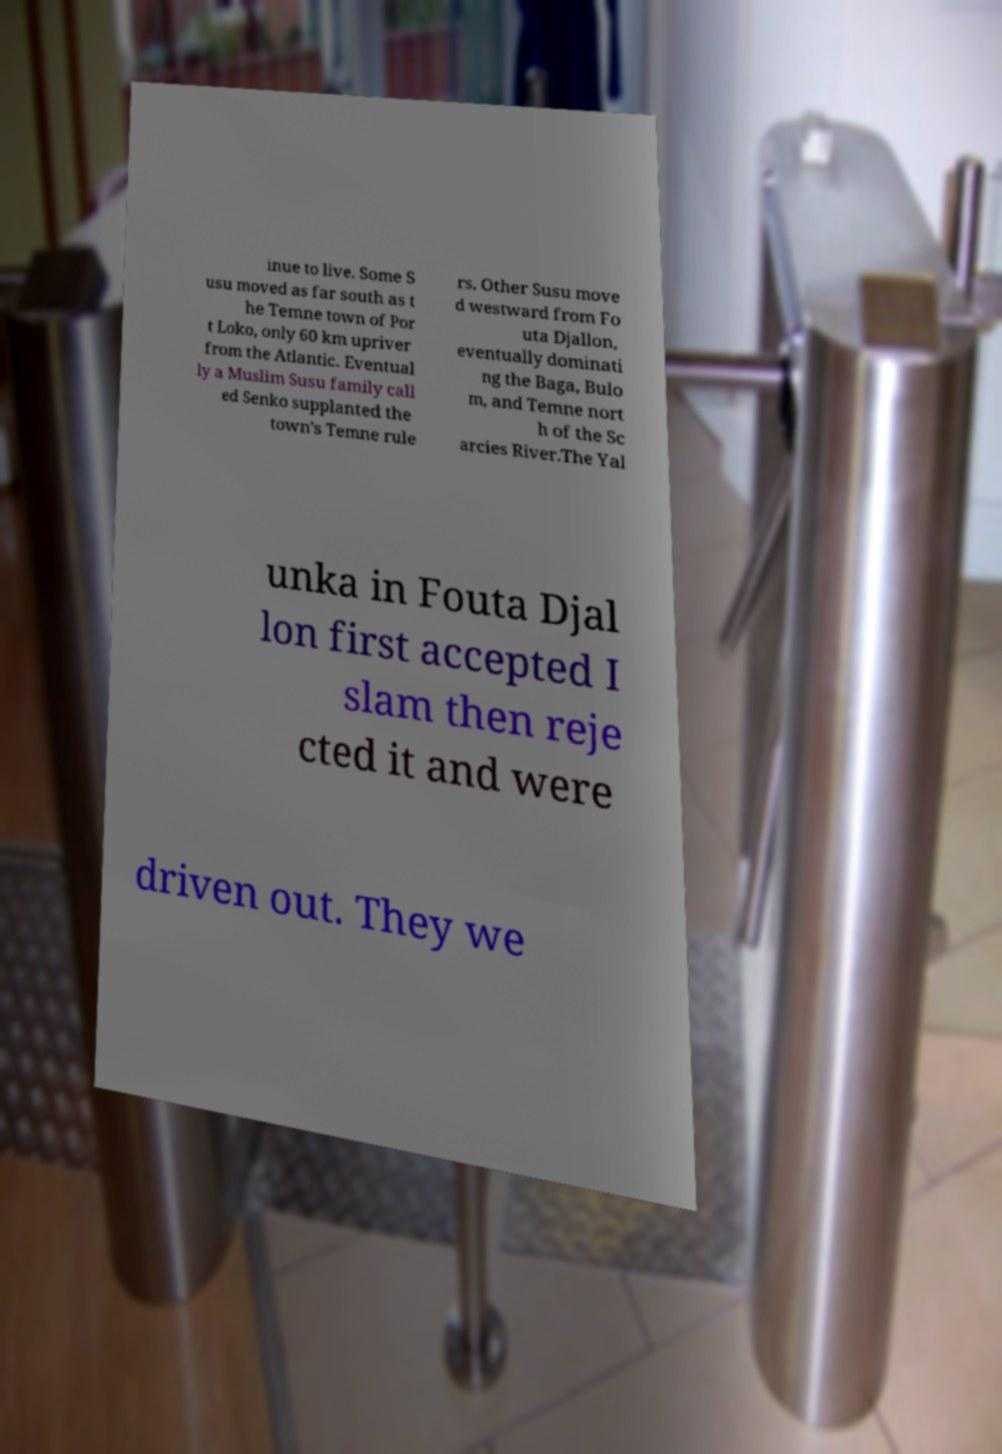What messages or text are displayed in this image? I need them in a readable, typed format. inue to live. Some S usu moved as far south as t he Temne town of Por t Loko, only 60 km upriver from the Atlantic. Eventual ly a Muslim Susu family call ed Senko supplanted the town's Temne rule rs. Other Susu move d westward from Fo uta Djallon, eventually dominati ng the Baga, Bulo m, and Temne nort h of the Sc arcies River.The Yal unka in Fouta Djal lon first accepted I slam then reje cted it and were driven out. They we 